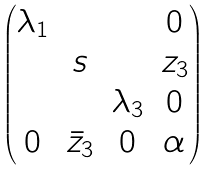<formula> <loc_0><loc_0><loc_500><loc_500>\begin{pmatrix} \lambda _ { 1 } & & & 0 \\ & s & & z _ { 3 } \\ & & \lambda _ { 3 } & 0 \\ 0 & \bar { z } _ { 3 } & 0 & \alpha \end{pmatrix}</formula> 